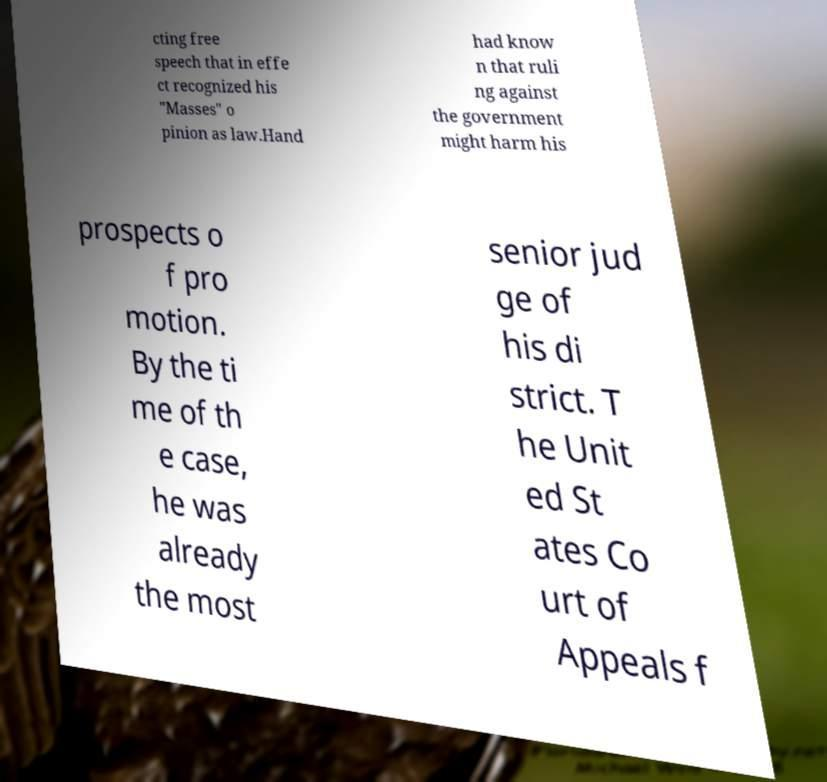Please read and relay the text visible in this image. What does it say? cting free speech that in effe ct recognized his "Masses" o pinion as law.Hand had know n that ruli ng against the government might harm his prospects o f pro motion. By the ti me of th e case, he was already the most senior jud ge of his di strict. T he Unit ed St ates Co urt of Appeals f 